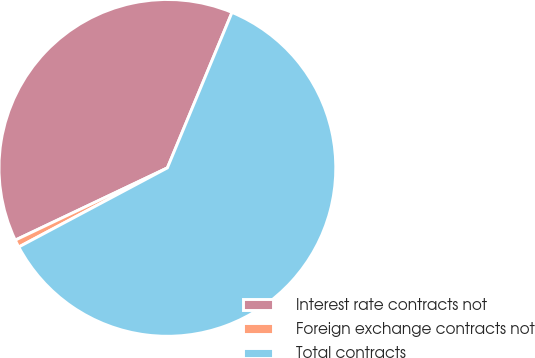Convert chart. <chart><loc_0><loc_0><loc_500><loc_500><pie_chart><fcel>Interest rate contracts not<fcel>Foreign exchange contracts not<fcel>Total contracts<nl><fcel>38.33%<fcel>0.73%<fcel>60.95%<nl></chart> 